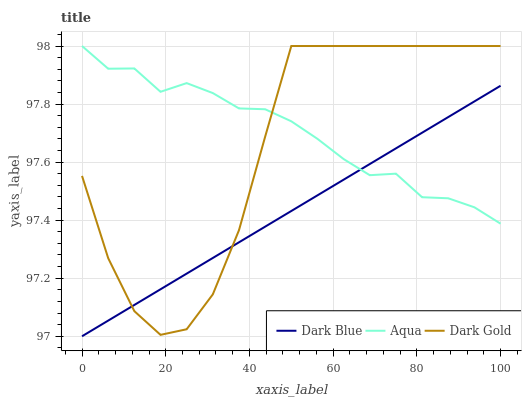Does Dark Blue have the minimum area under the curve?
Answer yes or no. Yes. Does Aqua have the maximum area under the curve?
Answer yes or no. Yes. Does Dark Gold have the minimum area under the curve?
Answer yes or no. No. Does Dark Gold have the maximum area under the curve?
Answer yes or no. No. Is Dark Blue the smoothest?
Answer yes or no. Yes. Is Dark Gold the roughest?
Answer yes or no. Yes. Is Aqua the smoothest?
Answer yes or no. No. Is Aqua the roughest?
Answer yes or no. No. Does Dark Blue have the lowest value?
Answer yes or no. Yes. Does Dark Gold have the lowest value?
Answer yes or no. No. Does Dark Gold have the highest value?
Answer yes or no. Yes. Does Aqua intersect Dark Gold?
Answer yes or no. Yes. Is Aqua less than Dark Gold?
Answer yes or no. No. Is Aqua greater than Dark Gold?
Answer yes or no. No. 